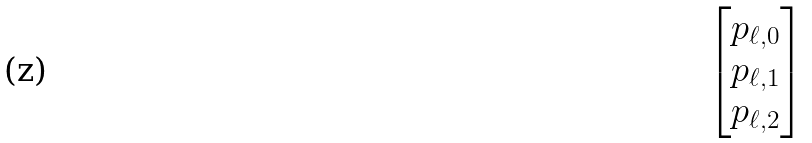<formula> <loc_0><loc_0><loc_500><loc_500>\begin{bmatrix} p _ { \ell , 0 } \\ p _ { \ell , 1 } \\ p _ { \ell , 2 } \end{bmatrix}</formula> 